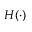Convert formula to latex. <formula><loc_0><loc_0><loc_500><loc_500>H ( \cdot )</formula> 